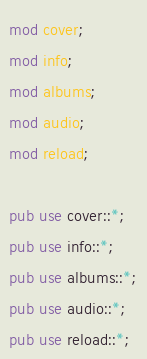Convert code to text. <code><loc_0><loc_0><loc_500><loc_500><_Rust_>mod cover;
mod info;
mod albums;
mod audio;
mod reload;

pub use cover::*;
pub use info::*;
pub use albums::*;
pub use audio::*;
pub use reload::*;</code> 